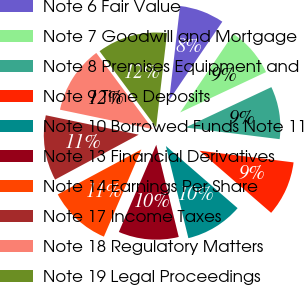<chart> <loc_0><loc_0><loc_500><loc_500><pie_chart><fcel>Note 6 Fair Value<fcel>Note 7 Goodwill and Mortgage<fcel>Note 8 Premises Equipment and<fcel>Note 9 Time Deposits<fcel>Note 10 Borrowed Funds Note 11<fcel>Note 13 Financial Derivatives<fcel>Note 14 Earnings Per Share<fcel>Note 17 Income Taxes<fcel>Note 18 Regulatory Matters<fcel>Note 19 Legal Proceedings<nl><fcel>7.64%<fcel>8.53%<fcel>8.96%<fcel>9.4%<fcel>9.83%<fcel>10.26%<fcel>10.7%<fcel>11.13%<fcel>11.56%<fcel>12.0%<nl></chart> 